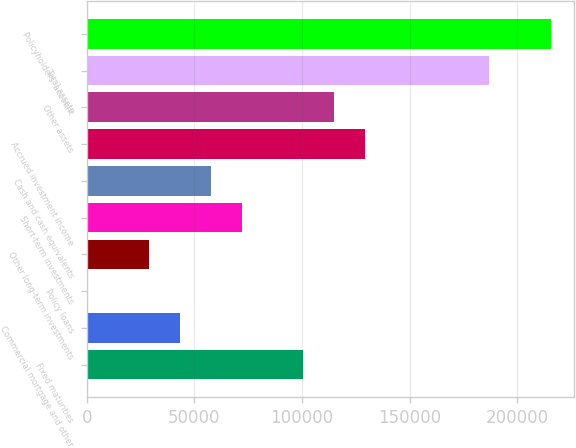<chart> <loc_0><loc_0><loc_500><loc_500><bar_chart><fcel>Fixed maturities<fcel>Commercial mortgage and other<fcel>Policy loans<fcel>Other long-term investments<fcel>Short-term investments<fcel>Cash and cash equivalents<fcel>Accrued investment income<fcel>Other assets<fcel>Total assets<fcel>Policyholders' account<nl><fcel>100643<fcel>43133.3<fcel>1.18<fcel>28755.9<fcel>71888.1<fcel>57510.7<fcel>129398<fcel>115020<fcel>186907<fcel>215662<nl></chart> 